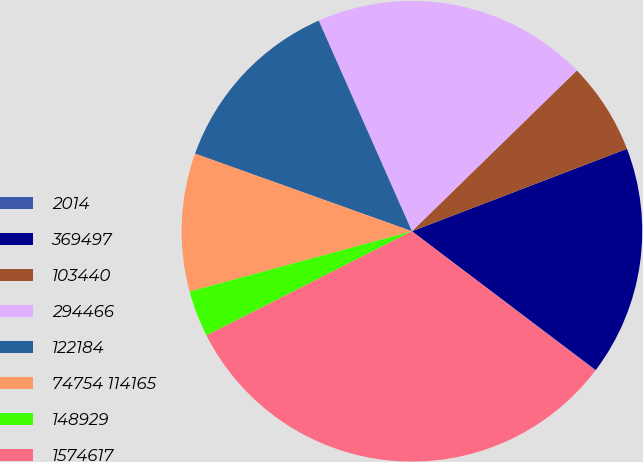Convert chart to OTSL. <chart><loc_0><loc_0><loc_500><loc_500><pie_chart><fcel>2014<fcel>369497<fcel>103440<fcel>294466<fcel>122184<fcel>74754 114165<fcel>148929<fcel>1574617<nl><fcel>0.04%<fcel>16.12%<fcel>6.47%<fcel>19.33%<fcel>12.9%<fcel>9.69%<fcel>3.25%<fcel>32.2%<nl></chart> 